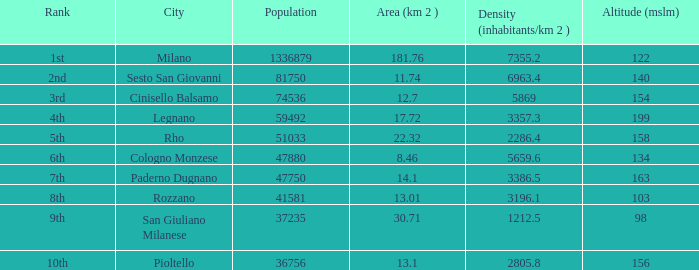Which Altitude (mslm) is the highest one that has a City of legnano, and a Population larger than 59492? None. 